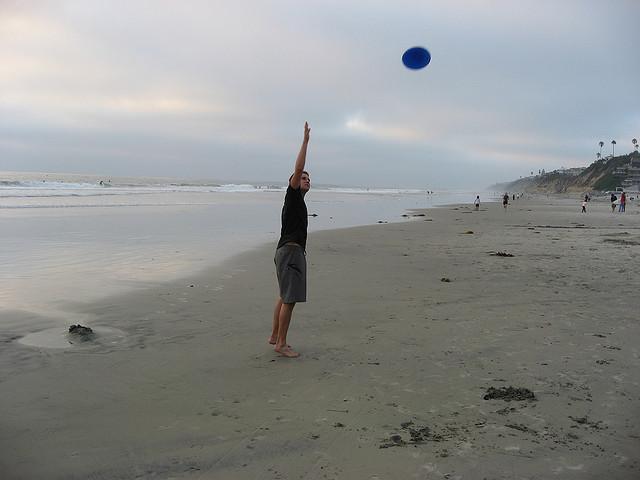What is trying to peek through the clouds?
Keep it brief. Sun. What is behind him?
Write a very short answer. Ocean. Is he doing a wallride?
Keep it brief. No. Is this a white sand beach?
Keep it brief. No. Is this a beach?
Answer briefly. Yes. Is the person going to injure himself?
Short answer required. No. Is this dangerous?
Keep it brief. No. Is there snow?
Concise answer only. No. What is he trying to catch?
Write a very short answer. Frisbee. Is the beach sand tan?
Answer briefly. Yes. 